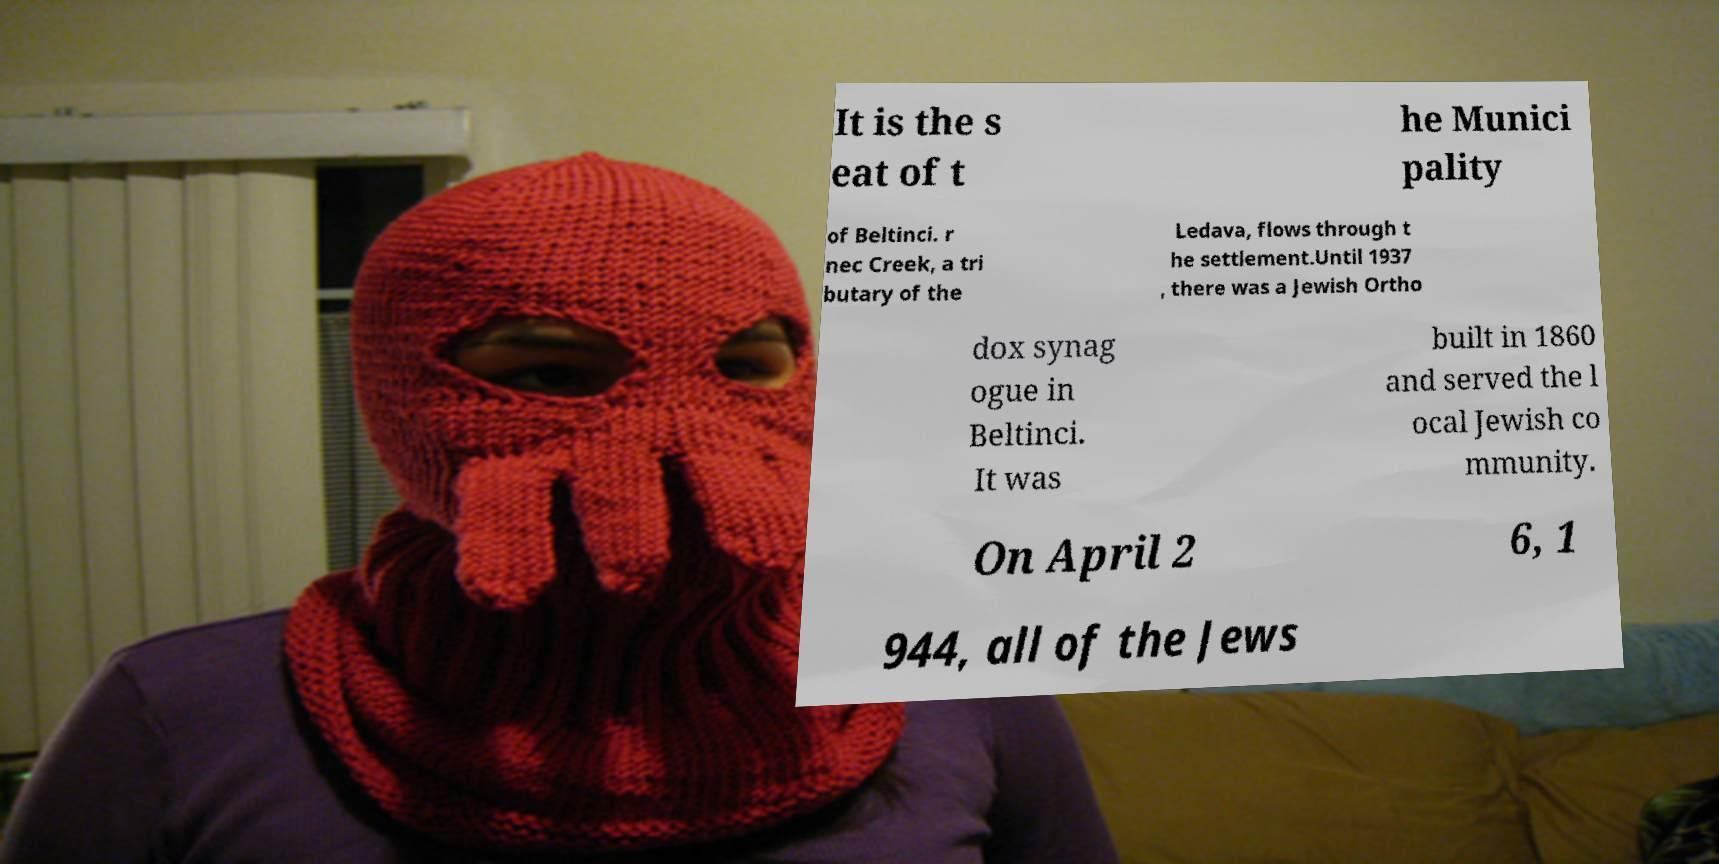Can you read and provide the text displayed in the image?This photo seems to have some interesting text. Can you extract and type it out for me? It is the s eat of t he Munici pality of Beltinci. r nec Creek, a tri butary of the Ledava, flows through t he settlement.Until 1937 , there was a Jewish Ortho dox synag ogue in Beltinci. It was built in 1860 and served the l ocal Jewish co mmunity. On April 2 6, 1 944, all of the Jews 